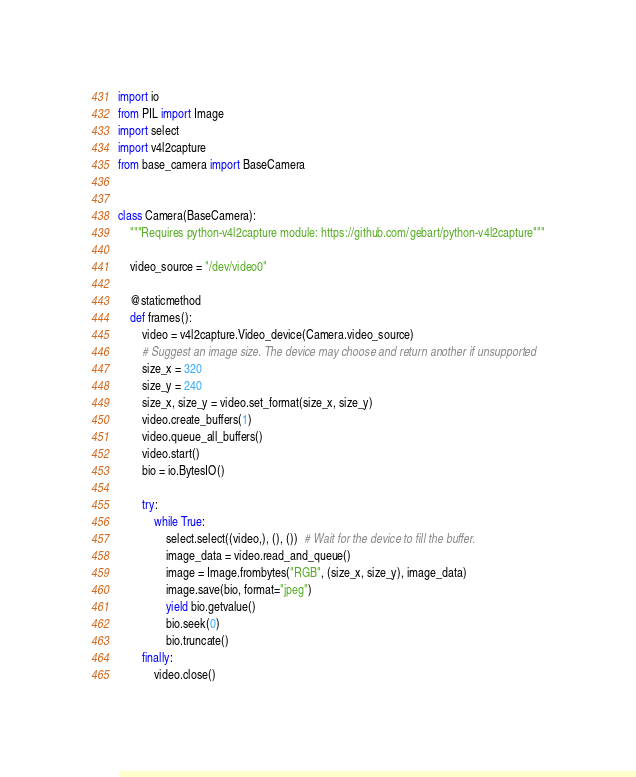Convert code to text. <code><loc_0><loc_0><loc_500><loc_500><_Python_>import io
from PIL import Image
import select
import v4l2capture
from base_camera import BaseCamera


class Camera(BaseCamera):
    """Requires python-v4l2capture module: https://github.com/gebart/python-v4l2capture"""

    video_source = "/dev/video0"

    @staticmethod
    def frames():
        video = v4l2capture.Video_device(Camera.video_source)
        # Suggest an image size. The device may choose and return another if unsupported
        size_x = 320
        size_y = 240
        size_x, size_y = video.set_format(size_x, size_y)
        video.create_buffers(1)
        video.queue_all_buffers()
        video.start()
        bio = io.BytesIO()

        try:
            while True:
                select.select((video,), (), ())  # Wait for the device to fill the buffer.
                image_data = video.read_and_queue()
                image = Image.frombytes("RGB", (size_x, size_y), image_data)
                image.save(bio, format="jpeg")
                yield bio.getvalue()
                bio.seek(0)
                bio.truncate()
        finally:
            video.close()
</code> 